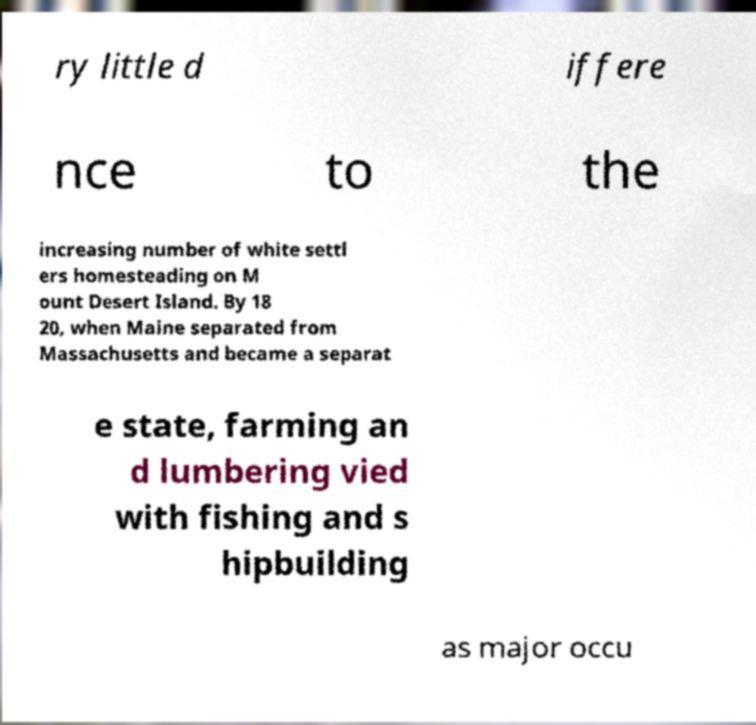What messages or text are displayed in this image? I need them in a readable, typed format. ry little d iffere nce to the increasing number of white settl ers homesteading on M ount Desert Island. By 18 20, when Maine separated from Massachusetts and became a separat e state, farming an d lumbering vied with fishing and s hipbuilding as major occu 